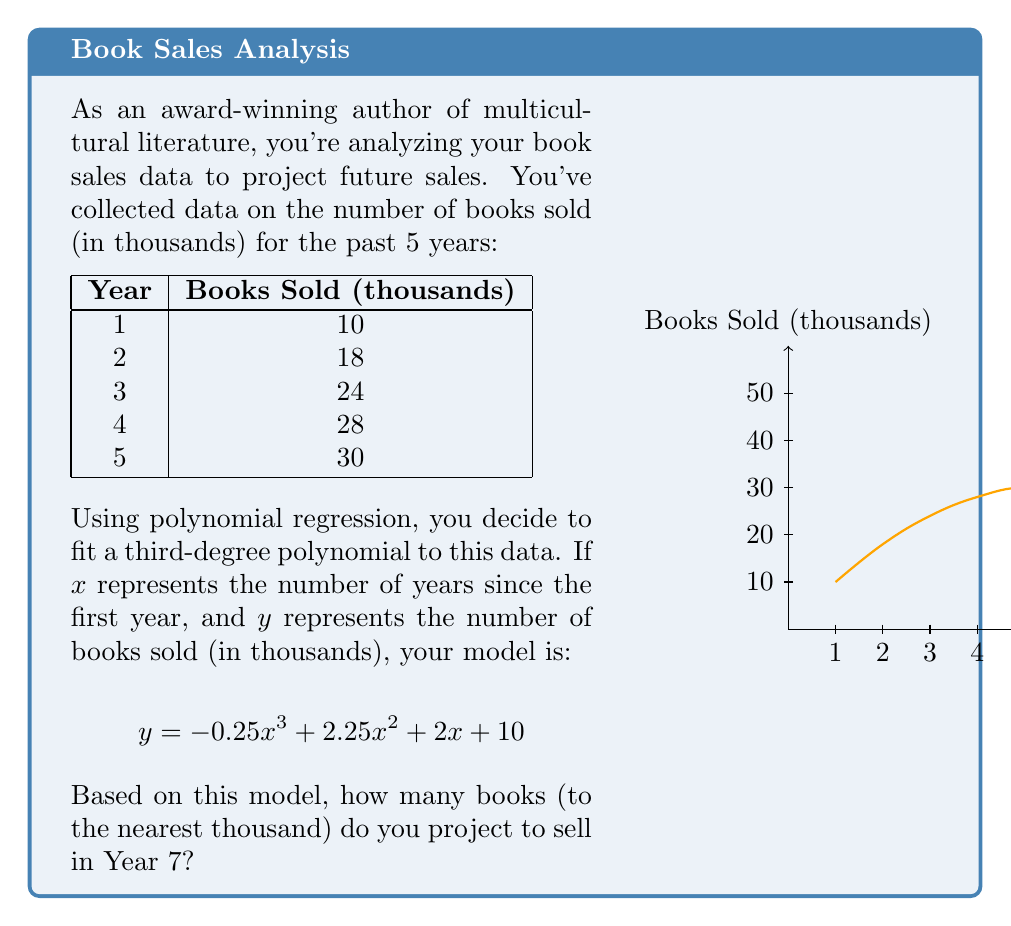Provide a solution to this math problem. Let's approach this step-by-step:

1) We have the polynomial regression model:
   $$y = -0.25x^3 + 2.25x^2 + 2x + 10$$

2) We need to find $y$ when $x = 6$ (because Year 7 is 6 years after Year 1).

3) Let's substitute $x = 6$ into our equation:
   $$y = -0.25(6)^3 + 2.25(6)^2 + 2(6) + 10$$

4) Now, let's calculate each term:
   - $-0.25(6)^3 = -0.25 * 216 = -54$
   - $2.25(6)^2 = 2.25 * 36 = 81$
   - $2(6) = 12$
   - The constant term is 10

5) Sum up all terms:
   $$y = -54 + 81 + 12 + 10 = 49$$

6) Therefore, the model projects 49,000 books to be sold in Year 7.

7) Rounding to the nearest thousand gives us 49,000.
Answer: 49,000 books 